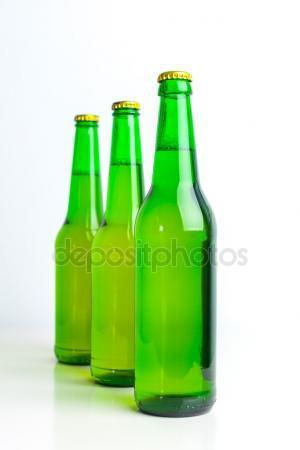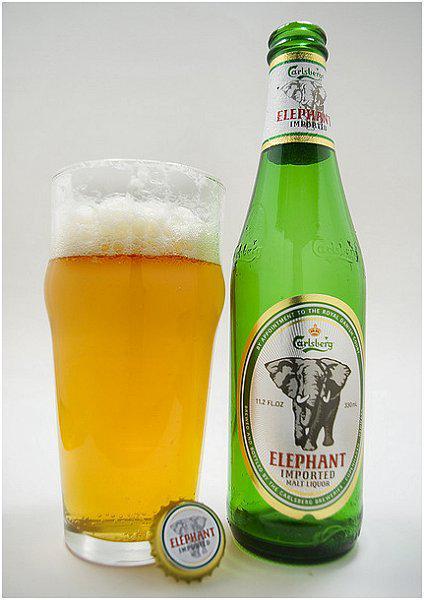The first image is the image on the left, the second image is the image on the right. Considering the images on both sides, is "All the bottles are full." valid? Answer yes or no. No. The first image is the image on the left, the second image is the image on the right. Examine the images to the left and right. Is the description "One image contains a diagonal row of three overlapping green bottles with liquid inside and caps on." accurate? Answer yes or no. Yes. 